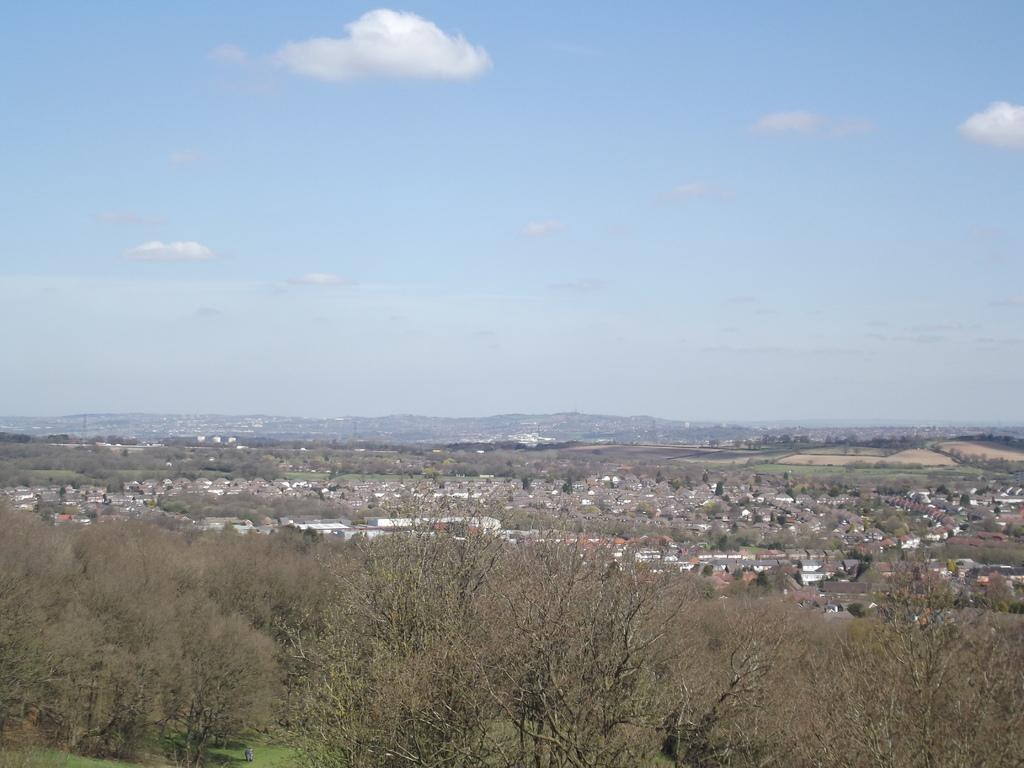What type of vegetation is present at the bottom of the image? There are trees and grass at the bottom of the image. What can be seen in the background of the image? There are mountains, trees, and buildings in the background of the image. What is visible at the top of the image? The sky is visible at the top of the image. What type of cork can be seen in the image? There is no cork present in the image. How does the butter contribute to the image? There is no butter present in the image. 